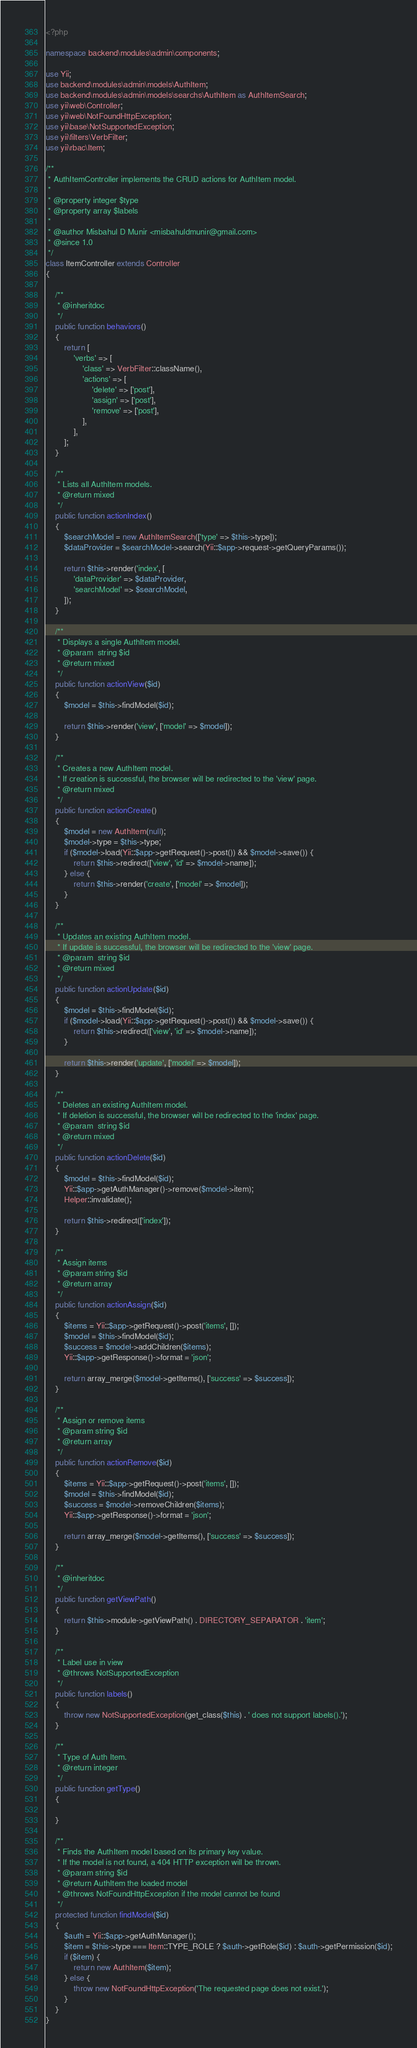<code> <loc_0><loc_0><loc_500><loc_500><_PHP_><?php

namespace backend\modules\admin\components;

use Yii;
use backend\modules\admin\models\AuthItem;
use backend\modules\admin\models\searchs\AuthItem as AuthItemSearch;
use yii\web\Controller;
use yii\web\NotFoundHttpException;
use yii\base\NotSupportedException;
use yii\filters\VerbFilter;
use yii\rbac\Item;

/**
 * AuthItemController implements the CRUD actions for AuthItem model.
 *
 * @property integer $type
 * @property array $labels
 * 
 * @author Misbahul D Munir <misbahuldmunir@gmail.com>
 * @since 1.0
 */
class ItemController extends Controller
{

    /**
     * @inheritdoc
     */
    public function behaviors()
    {
        return [
            'verbs' => [
                'class' => VerbFilter::className(),
                'actions' => [
                    'delete' => ['post'],
                    'assign' => ['post'],
                    'remove' => ['post'],
                ],
            ],
        ];
    }

    /**
     * Lists all AuthItem models.
     * @return mixed
     */
    public function actionIndex()
    {
        $searchModel = new AuthItemSearch(['type' => $this->type]);
        $dataProvider = $searchModel->search(Yii::$app->request->getQueryParams());

        return $this->render('index', [
            'dataProvider' => $dataProvider,
            'searchModel' => $searchModel,
        ]);
    }

    /**
     * Displays a single AuthItem model.
     * @param  string $id
     * @return mixed
     */
    public function actionView($id)
    {
        $model = $this->findModel($id);

        return $this->render('view', ['model' => $model]);
    }

    /**
     * Creates a new AuthItem model.
     * If creation is successful, the browser will be redirected to the 'view' page.
     * @return mixed
     */
    public function actionCreate()
    {
        $model = new AuthItem(null);
        $model->type = $this->type;
        if ($model->load(Yii::$app->getRequest()->post()) && $model->save()) {
            return $this->redirect(['view', 'id' => $model->name]);
        } else {
            return $this->render('create', ['model' => $model]);
        }
    }

    /**
     * Updates an existing AuthItem model.
     * If update is successful, the browser will be redirected to the 'view' page.
     * @param  string $id
     * @return mixed
     */
    public function actionUpdate($id)
    {
        $model = $this->findModel($id);
        if ($model->load(Yii::$app->getRequest()->post()) && $model->save()) {
            return $this->redirect(['view', 'id' => $model->name]);
        }

        return $this->render('update', ['model' => $model]);
    }

    /**
     * Deletes an existing AuthItem model.
     * If deletion is successful, the browser will be redirected to the 'index' page.
     * @param  string $id
     * @return mixed
     */
    public function actionDelete($id)
    {
        $model = $this->findModel($id);
        Yii::$app->getAuthManager()->remove($model->item);
        Helper::invalidate();

        return $this->redirect(['index']);
    }

    /**
     * Assign items
     * @param string $id
     * @return array
     */
    public function actionAssign($id)
    {
        $items = Yii::$app->getRequest()->post('items', []);
        $model = $this->findModel($id);
        $success = $model->addChildren($items);
        Yii::$app->getResponse()->format = 'json';

        return array_merge($model->getItems(), ['success' => $success]);
    }

    /**
     * Assign or remove items
     * @param string $id
     * @return array
     */
    public function actionRemove($id)
    {
        $items = Yii::$app->getRequest()->post('items', []);
        $model = $this->findModel($id);
        $success = $model->removeChildren($items);
        Yii::$app->getResponse()->format = 'json';

        return array_merge($model->getItems(), ['success' => $success]);
    }

    /**
     * @inheritdoc
     */
    public function getViewPath()
    {
        return $this->module->getViewPath() . DIRECTORY_SEPARATOR . 'item';
    }

    /**
     * Label use in view
     * @throws NotSupportedException
     */
    public function labels()
    {
        throw new NotSupportedException(get_class($this) . ' does not support labels().');
    }

    /**
     * Type of Auth Item.
     * @return integer
     */
    public function getType()
    {
        
    }

    /**
     * Finds the AuthItem model based on its primary key value.
     * If the model is not found, a 404 HTTP exception will be thrown.
     * @param string $id
     * @return AuthItem the loaded model
     * @throws NotFoundHttpException if the model cannot be found
     */
    protected function findModel($id)
    {
        $auth = Yii::$app->getAuthManager();
        $item = $this->type === Item::TYPE_ROLE ? $auth->getRole($id) : $auth->getPermission($id);
        if ($item) {
            return new AuthItem($item);
        } else {
            throw new NotFoundHttpException('The requested page does not exist.');
        }
    }
}
</code> 